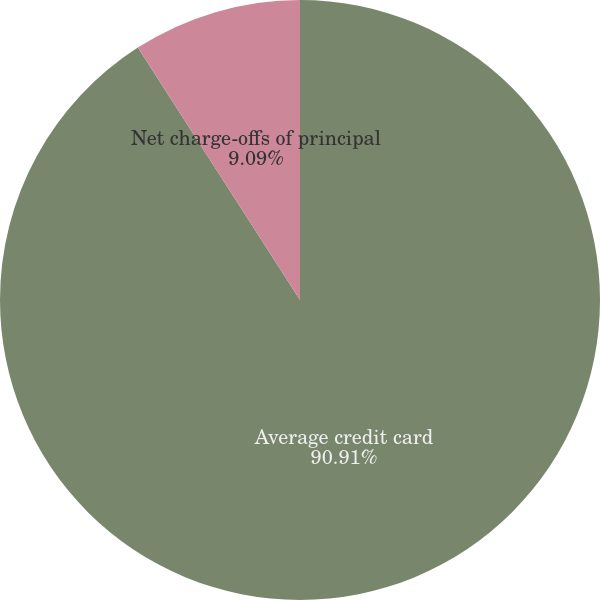Convert chart. <chart><loc_0><loc_0><loc_500><loc_500><pie_chart><fcel>Average credit card<fcel>Net charge-offs of principal<fcel>Net charge-offs as a<nl><fcel>90.91%<fcel>9.09%<fcel>0.0%<nl></chart> 